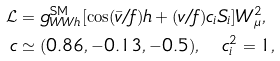<formula> <loc_0><loc_0><loc_500><loc_500>\mathcal { L } & = g _ { W W h } ^ { \text {SM} } [ \cos ( \bar { v } / f ) h + ( v / f ) c _ { i } S _ { i } ] W _ { \mu } ^ { 2 } , \\ c & \simeq ( 0 . 8 6 , - 0 . 1 3 , - 0 . 5 ) , \quad c _ { i } ^ { 2 } = 1 ,</formula> 